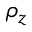<formula> <loc_0><loc_0><loc_500><loc_500>\rho _ { z }</formula> 